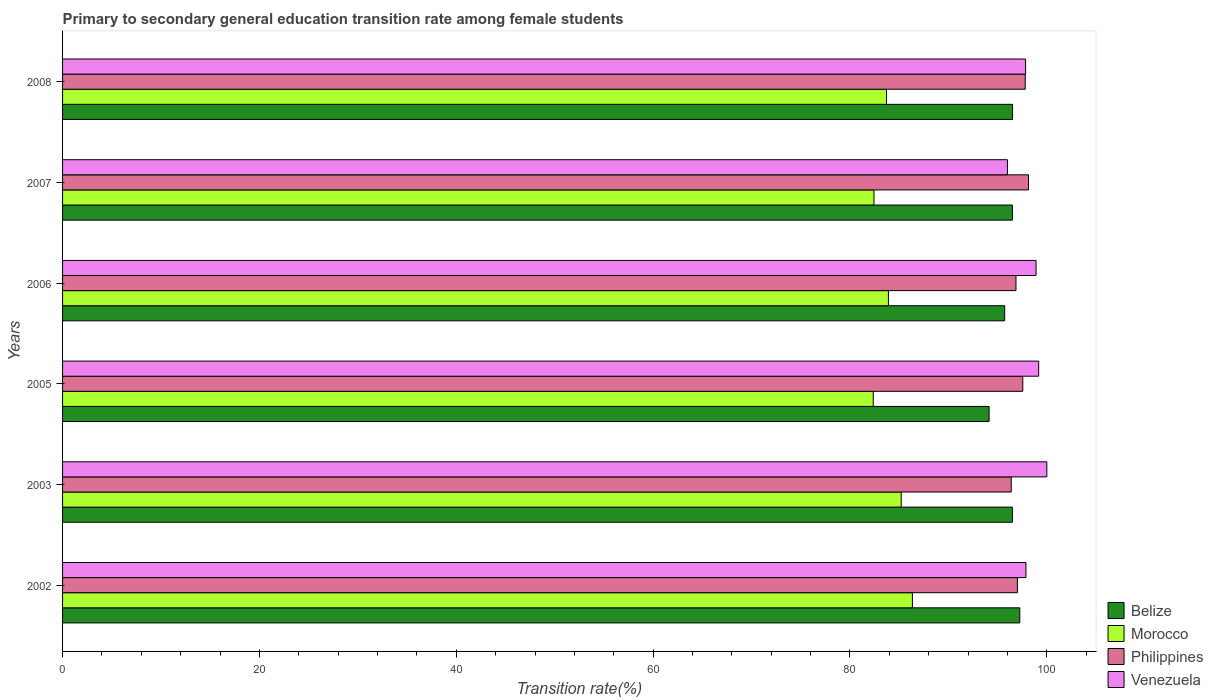How many different coloured bars are there?
Ensure brevity in your answer.  4. How many groups of bars are there?
Your response must be concise. 6. How many bars are there on the 5th tick from the top?
Offer a very short reply. 4. What is the label of the 1st group of bars from the top?
Provide a short and direct response. 2008. Across all years, what is the minimum transition rate in Morocco?
Keep it short and to the point. 82.36. What is the total transition rate in Belize in the graph?
Offer a very short reply. 576.63. What is the difference between the transition rate in Morocco in 2005 and that in 2007?
Give a very brief answer. -0.08. What is the difference between the transition rate in Morocco in 2005 and the transition rate in Philippines in 2002?
Your answer should be very brief. -14.65. What is the average transition rate in Morocco per year?
Give a very brief answer. 83.99. In the year 2006, what is the difference between the transition rate in Venezuela and transition rate in Belize?
Provide a short and direct response. 3.19. In how many years, is the transition rate in Philippines greater than 56 %?
Your answer should be very brief. 6. What is the ratio of the transition rate in Morocco in 2003 to that in 2005?
Give a very brief answer. 1.03. Is the transition rate in Belize in 2005 less than that in 2006?
Make the answer very short. Yes. Is the difference between the transition rate in Venezuela in 2003 and 2007 greater than the difference between the transition rate in Belize in 2003 and 2007?
Give a very brief answer. Yes. What is the difference between the highest and the second highest transition rate in Philippines?
Make the answer very short. 0.33. What is the difference between the highest and the lowest transition rate in Venezuela?
Make the answer very short. 4. In how many years, is the transition rate in Morocco greater than the average transition rate in Morocco taken over all years?
Your answer should be very brief. 2. What does the 4th bar from the top in 2008 represents?
Provide a succinct answer. Belize. What does the 4th bar from the bottom in 2003 represents?
Your response must be concise. Venezuela. Is it the case that in every year, the sum of the transition rate in Morocco and transition rate in Venezuela is greater than the transition rate in Philippines?
Your answer should be very brief. Yes. How many bars are there?
Your response must be concise. 24. Where does the legend appear in the graph?
Your response must be concise. Bottom right. How are the legend labels stacked?
Keep it short and to the point. Vertical. What is the title of the graph?
Make the answer very short. Primary to secondary general education transition rate among female students. What is the label or title of the X-axis?
Ensure brevity in your answer.  Transition rate(%). What is the Transition rate(%) in Belize in 2002?
Offer a very short reply. 97.25. What is the Transition rate(%) of Morocco in 2002?
Offer a very short reply. 86.34. What is the Transition rate(%) in Philippines in 2002?
Make the answer very short. 97.01. What is the Transition rate(%) in Venezuela in 2002?
Offer a very short reply. 97.88. What is the Transition rate(%) in Belize in 2003?
Provide a succinct answer. 96.5. What is the Transition rate(%) of Morocco in 2003?
Provide a succinct answer. 85.21. What is the Transition rate(%) in Philippines in 2003?
Provide a short and direct response. 96.38. What is the Transition rate(%) of Venezuela in 2003?
Provide a short and direct response. 100. What is the Transition rate(%) of Belize in 2005?
Keep it short and to the point. 94.13. What is the Transition rate(%) in Morocco in 2005?
Provide a succinct answer. 82.36. What is the Transition rate(%) of Philippines in 2005?
Provide a succinct answer. 97.56. What is the Transition rate(%) in Venezuela in 2005?
Ensure brevity in your answer.  99.17. What is the Transition rate(%) of Belize in 2006?
Provide a short and direct response. 95.72. What is the Transition rate(%) in Morocco in 2006?
Give a very brief answer. 83.91. What is the Transition rate(%) of Philippines in 2006?
Provide a short and direct response. 96.86. What is the Transition rate(%) of Venezuela in 2006?
Your answer should be compact. 98.91. What is the Transition rate(%) of Belize in 2007?
Ensure brevity in your answer.  96.51. What is the Transition rate(%) in Morocco in 2007?
Your answer should be compact. 82.44. What is the Transition rate(%) in Philippines in 2007?
Offer a terse response. 98.14. What is the Transition rate(%) in Venezuela in 2007?
Ensure brevity in your answer.  96. What is the Transition rate(%) of Belize in 2008?
Provide a succinct answer. 96.52. What is the Transition rate(%) of Morocco in 2008?
Make the answer very short. 83.71. What is the Transition rate(%) of Philippines in 2008?
Give a very brief answer. 97.8. What is the Transition rate(%) of Venezuela in 2008?
Provide a short and direct response. 97.84. Across all years, what is the maximum Transition rate(%) in Belize?
Give a very brief answer. 97.25. Across all years, what is the maximum Transition rate(%) in Morocco?
Your response must be concise. 86.34. Across all years, what is the maximum Transition rate(%) of Philippines?
Keep it short and to the point. 98.14. Across all years, what is the minimum Transition rate(%) in Belize?
Keep it short and to the point. 94.13. Across all years, what is the minimum Transition rate(%) in Morocco?
Make the answer very short. 82.36. Across all years, what is the minimum Transition rate(%) in Philippines?
Ensure brevity in your answer.  96.38. Across all years, what is the minimum Transition rate(%) in Venezuela?
Provide a short and direct response. 96. What is the total Transition rate(%) in Belize in the graph?
Ensure brevity in your answer.  576.63. What is the total Transition rate(%) in Morocco in the graph?
Your answer should be very brief. 503.97. What is the total Transition rate(%) of Philippines in the graph?
Offer a terse response. 583.76. What is the total Transition rate(%) in Venezuela in the graph?
Ensure brevity in your answer.  589.8. What is the difference between the Transition rate(%) of Belize in 2002 and that in 2003?
Provide a succinct answer. 0.75. What is the difference between the Transition rate(%) in Morocco in 2002 and that in 2003?
Provide a succinct answer. 1.14. What is the difference between the Transition rate(%) in Philippines in 2002 and that in 2003?
Your response must be concise. 0.63. What is the difference between the Transition rate(%) of Venezuela in 2002 and that in 2003?
Your response must be concise. -2.12. What is the difference between the Transition rate(%) in Belize in 2002 and that in 2005?
Make the answer very short. 3.12. What is the difference between the Transition rate(%) in Morocco in 2002 and that in 2005?
Provide a short and direct response. 3.98. What is the difference between the Transition rate(%) in Philippines in 2002 and that in 2005?
Offer a very short reply. -0.55. What is the difference between the Transition rate(%) in Venezuela in 2002 and that in 2005?
Offer a very short reply. -1.29. What is the difference between the Transition rate(%) in Belize in 2002 and that in 2006?
Offer a very short reply. 1.53. What is the difference between the Transition rate(%) of Morocco in 2002 and that in 2006?
Your response must be concise. 2.44. What is the difference between the Transition rate(%) of Philippines in 2002 and that in 2006?
Ensure brevity in your answer.  0.15. What is the difference between the Transition rate(%) in Venezuela in 2002 and that in 2006?
Offer a very short reply. -1.02. What is the difference between the Transition rate(%) of Belize in 2002 and that in 2007?
Keep it short and to the point. 0.74. What is the difference between the Transition rate(%) of Morocco in 2002 and that in 2007?
Provide a succinct answer. 3.9. What is the difference between the Transition rate(%) in Philippines in 2002 and that in 2007?
Your answer should be compact. -1.13. What is the difference between the Transition rate(%) in Venezuela in 2002 and that in 2007?
Your answer should be compact. 1.88. What is the difference between the Transition rate(%) in Belize in 2002 and that in 2008?
Ensure brevity in your answer.  0.73. What is the difference between the Transition rate(%) in Morocco in 2002 and that in 2008?
Give a very brief answer. 2.63. What is the difference between the Transition rate(%) of Philippines in 2002 and that in 2008?
Your answer should be very brief. -0.79. What is the difference between the Transition rate(%) of Venezuela in 2002 and that in 2008?
Offer a terse response. 0.04. What is the difference between the Transition rate(%) of Belize in 2003 and that in 2005?
Offer a very short reply. 2.37. What is the difference between the Transition rate(%) in Morocco in 2003 and that in 2005?
Provide a succinct answer. 2.84. What is the difference between the Transition rate(%) in Philippines in 2003 and that in 2005?
Offer a very short reply. -1.17. What is the difference between the Transition rate(%) in Venezuela in 2003 and that in 2005?
Offer a terse response. 0.83. What is the difference between the Transition rate(%) of Belize in 2003 and that in 2006?
Provide a short and direct response. 0.78. What is the difference between the Transition rate(%) in Morocco in 2003 and that in 2006?
Your response must be concise. 1.3. What is the difference between the Transition rate(%) of Philippines in 2003 and that in 2006?
Your response must be concise. -0.48. What is the difference between the Transition rate(%) in Venezuela in 2003 and that in 2006?
Keep it short and to the point. 1.09. What is the difference between the Transition rate(%) in Belize in 2003 and that in 2007?
Give a very brief answer. -0.01. What is the difference between the Transition rate(%) in Morocco in 2003 and that in 2007?
Offer a terse response. 2.77. What is the difference between the Transition rate(%) of Philippines in 2003 and that in 2007?
Your answer should be very brief. -1.75. What is the difference between the Transition rate(%) in Venezuela in 2003 and that in 2007?
Your answer should be very brief. 4. What is the difference between the Transition rate(%) of Belize in 2003 and that in 2008?
Keep it short and to the point. -0.02. What is the difference between the Transition rate(%) in Morocco in 2003 and that in 2008?
Your answer should be very brief. 1.5. What is the difference between the Transition rate(%) of Philippines in 2003 and that in 2008?
Offer a very short reply. -1.42. What is the difference between the Transition rate(%) in Venezuela in 2003 and that in 2008?
Ensure brevity in your answer.  2.16. What is the difference between the Transition rate(%) of Belize in 2005 and that in 2006?
Your answer should be very brief. -1.58. What is the difference between the Transition rate(%) in Morocco in 2005 and that in 2006?
Ensure brevity in your answer.  -1.54. What is the difference between the Transition rate(%) of Philippines in 2005 and that in 2006?
Your answer should be very brief. 0.69. What is the difference between the Transition rate(%) in Venezuela in 2005 and that in 2006?
Your response must be concise. 0.27. What is the difference between the Transition rate(%) of Belize in 2005 and that in 2007?
Provide a short and direct response. -2.37. What is the difference between the Transition rate(%) in Morocco in 2005 and that in 2007?
Ensure brevity in your answer.  -0.08. What is the difference between the Transition rate(%) in Philippines in 2005 and that in 2007?
Give a very brief answer. -0.58. What is the difference between the Transition rate(%) in Venezuela in 2005 and that in 2007?
Offer a terse response. 3.17. What is the difference between the Transition rate(%) in Belize in 2005 and that in 2008?
Your answer should be compact. -2.38. What is the difference between the Transition rate(%) in Morocco in 2005 and that in 2008?
Your answer should be compact. -1.35. What is the difference between the Transition rate(%) in Philippines in 2005 and that in 2008?
Give a very brief answer. -0.25. What is the difference between the Transition rate(%) in Venezuela in 2005 and that in 2008?
Provide a succinct answer. 1.33. What is the difference between the Transition rate(%) in Belize in 2006 and that in 2007?
Your response must be concise. -0.79. What is the difference between the Transition rate(%) in Morocco in 2006 and that in 2007?
Give a very brief answer. 1.47. What is the difference between the Transition rate(%) of Philippines in 2006 and that in 2007?
Offer a very short reply. -1.27. What is the difference between the Transition rate(%) of Venezuela in 2006 and that in 2007?
Your response must be concise. 2.9. What is the difference between the Transition rate(%) of Belize in 2006 and that in 2008?
Give a very brief answer. -0.8. What is the difference between the Transition rate(%) of Morocco in 2006 and that in 2008?
Make the answer very short. 0.2. What is the difference between the Transition rate(%) of Philippines in 2006 and that in 2008?
Keep it short and to the point. -0.94. What is the difference between the Transition rate(%) of Venezuela in 2006 and that in 2008?
Provide a short and direct response. 1.07. What is the difference between the Transition rate(%) in Belize in 2007 and that in 2008?
Ensure brevity in your answer.  -0.01. What is the difference between the Transition rate(%) in Morocco in 2007 and that in 2008?
Your response must be concise. -1.27. What is the difference between the Transition rate(%) of Philippines in 2007 and that in 2008?
Your answer should be very brief. 0.33. What is the difference between the Transition rate(%) of Venezuela in 2007 and that in 2008?
Offer a very short reply. -1.84. What is the difference between the Transition rate(%) in Belize in 2002 and the Transition rate(%) in Morocco in 2003?
Ensure brevity in your answer.  12.05. What is the difference between the Transition rate(%) in Belize in 2002 and the Transition rate(%) in Philippines in 2003?
Keep it short and to the point. 0.87. What is the difference between the Transition rate(%) in Belize in 2002 and the Transition rate(%) in Venezuela in 2003?
Offer a terse response. -2.75. What is the difference between the Transition rate(%) in Morocco in 2002 and the Transition rate(%) in Philippines in 2003?
Offer a very short reply. -10.04. What is the difference between the Transition rate(%) of Morocco in 2002 and the Transition rate(%) of Venezuela in 2003?
Your answer should be compact. -13.66. What is the difference between the Transition rate(%) in Philippines in 2002 and the Transition rate(%) in Venezuela in 2003?
Your answer should be compact. -2.99. What is the difference between the Transition rate(%) in Belize in 2002 and the Transition rate(%) in Morocco in 2005?
Give a very brief answer. 14.89. What is the difference between the Transition rate(%) of Belize in 2002 and the Transition rate(%) of Philippines in 2005?
Your response must be concise. -0.31. What is the difference between the Transition rate(%) in Belize in 2002 and the Transition rate(%) in Venezuela in 2005?
Make the answer very short. -1.92. What is the difference between the Transition rate(%) in Morocco in 2002 and the Transition rate(%) in Philippines in 2005?
Provide a short and direct response. -11.21. What is the difference between the Transition rate(%) of Morocco in 2002 and the Transition rate(%) of Venezuela in 2005?
Give a very brief answer. -12.83. What is the difference between the Transition rate(%) in Philippines in 2002 and the Transition rate(%) in Venezuela in 2005?
Your answer should be compact. -2.16. What is the difference between the Transition rate(%) of Belize in 2002 and the Transition rate(%) of Morocco in 2006?
Give a very brief answer. 13.34. What is the difference between the Transition rate(%) in Belize in 2002 and the Transition rate(%) in Philippines in 2006?
Your response must be concise. 0.39. What is the difference between the Transition rate(%) in Belize in 2002 and the Transition rate(%) in Venezuela in 2006?
Your response must be concise. -1.65. What is the difference between the Transition rate(%) in Morocco in 2002 and the Transition rate(%) in Philippines in 2006?
Offer a terse response. -10.52. What is the difference between the Transition rate(%) of Morocco in 2002 and the Transition rate(%) of Venezuela in 2006?
Your response must be concise. -12.56. What is the difference between the Transition rate(%) of Philippines in 2002 and the Transition rate(%) of Venezuela in 2006?
Offer a very short reply. -1.9. What is the difference between the Transition rate(%) in Belize in 2002 and the Transition rate(%) in Morocco in 2007?
Provide a succinct answer. 14.81. What is the difference between the Transition rate(%) of Belize in 2002 and the Transition rate(%) of Philippines in 2007?
Keep it short and to the point. -0.89. What is the difference between the Transition rate(%) of Belize in 2002 and the Transition rate(%) of Venezuela in 2007?
Give a very brief answer. 1.25. What is the difference between the Transition rate(%) of Morocco in 2002 and the Transition rate(%) of Philippines in 2007?
Your response must be concise. -11.79. What is the difference between the Transition rate(%) in Morocco in 2002 and the Transition rate(%) in Venezuela in 2007?
Ensure brevity in your answer.  -9.66. What is the difference between the Transition rate(%) in Philippines in 2002 and the Transition rate(%) in Venezuela in 2007?
Keep it short and to the point. 1.01. What is the difference between the Transition rate(%) of Belize in 2002 and the Transition rate(%) of Morocco in 2008?
Provide a short and direct response. 13.54. What is the difference between the Transition rate(%) in Belize in 2002 and the Transition rate(%) in Philippines in 2008?
Keep it short and to the point. -0.55. What is the difference between the Transition rate(%) in Belize in 2002 and the Transition rate(%) in Venezuela in 2008?
Ensure brevity in your answer.  -0.59. What is the difference between the Transition rate(%) in Morocco in 2002 and the Transition rate(%) in Philippines in 2008?
Provide a succinct answer. -11.46. What is the difference between the Transition rate(%) in Morocco in 2002 and the Transition rate(%) in Venezuela in 2008?
Keep it short and to the point. -11.5. What is the difference between the Transition rate(%) in Philippines in 2002 and the Transition rate(%) in Venezuela in 2008?
Make the answer very short. -0.83. What is the difference between the Transition rate(%) in Belize in 2003 and the Transition rate(%) in Morocco in 2005?
Your answer should be very brief. 14.14. What is the difference between the Transition rate(%) in Belize in 2003 and the Transition rate(%) in Philippines in 2005?
Provide a short and direct response. -1.06. What is the difference between the Transition rate(%) of Belize in 2003 and the Transition rate(%) of Venezuela in 2005?
Your response must be concise. -2.67. What is the difference between the Transition rate(%) of Morocco in 2003 and the Transition rate(%) of Philippines in 2005?
Your response must be concise. -12.35. What is the difference between the Transition rate(%) of Morocco in 2003 and the Transition rate(%) of Venezuela in 2005?
Make the answer very short. -13.97. What is the difference between the Transition rate(%) of Philippines in 2003 and the Transition rate(%) of Venezuela in 2005?
Give a very brief answer. -2.79. What is the difference between the Transition rate(%) of Belize in 2003 and the Transition rate(%) of Morocco in 2006?
Ensure brevity in your answer.  12.6. What is the difference between the Transition rate(%) of Belize in 2003 and the Transition rate(%) of Philippines in 2006?
Ensure brevity in your answer.  -0.36. What is the difference between the Transition rate(%) in Belize in 2003 and the Transition rate(%) in Venezuela in 2006?
Give a very brief answer. -2.4. What is the difference between the Transition rate(%) in Morocco in 2003 and the Transition rate(%) in Philippines in 2006?
Your answer should be compact. -11.66. What is the difference between the Transition rate(%) in Morocco in 2003 and the Transition rate(%) in Venezuela in 2006?
Ensure brevity in your answer.  -13.7. What is the difference between the Transition rate(%) of Philippines in 2003 and the Transition rate(%) of Venezuela in 2006?
Make the answer very short. -2.52. What is the difference between the Transition rate(%) in Belize in 2003 and the Transition rate(%) in Morocco in 2007?
Your answer should be very brief. 14.06. What is the difference between the Transition rate(%) of Belize in 2003 and the Transition rate(%) of Philippines in 2007?
Ensure brevity in your answer.  -1.63. What is the difference between the Transition rate(%) of Belize in 2003 and the Transition rate(%) of Venezuela in 2007?
Ensure brevity in your answer.  0.5. What is the difference between the Transition rate(%) of Morocco in 2003 and the Transition rate(%) of Philippines in 2007?
Your answer should be very brief. -12.93. What is the difference between the Transition rate(%) of Morocco in 2003 and the Transition rate(%) of Venezuela in 2007?
Offer a terse response. -10.8. What is the difference between the Transition rate(%) of Philippines in 2003 and the Transition rate(%) of Venezuela in 2007?
Your answer should be very brief. 0.38. What is the difference between the Transition rate(%) in Belize in 2003 and the Transition rate(%) in Morocco in 2008?
Your answer should be compact. 12.79. What is the difference between the Transition rate(%) of Belize in 2003 and the Transition rate(%) of Philippines in 2008?
Your answer should be very brief. -1.3. What is the difference between the Transition rate(%) in Belize in 2003 and the Transition rate(%) in Venezuela in 2008?
Provide a short and direct response. -1.34. What is the difference between the Transition rate(%) in Morocco in 2003 and the Transition rate(%) in Philippines in 2008?
Offer a very short reply. -12.6. What is the difference between the Transition rate(%) in Morocco in 2003 and the Transition rate(%) in Venezuela in 2008?
Offer a very short reply. -12.63. What is the difference between the Transition rate(%) in Philippines in 2003 and the Transition rate(%) in Venezuela in 2008?
Offer a terse response. -1.46. What is the difference between the Transition rate(%) of Belize in 2005 and the Transition rate(%) of Morocco in 2006?
Your answer should be compact. 10.23. What is the difference between the Transition rate(%) in Belize in 2005 and the Transition rate(%) in Philippines in 2006?
Keep it short and to the point. -2.73. What is the difference between the Transition rate(%) in Belize in 2005 and the Transition rate(%) in Venezuela in 2006?
Your response must be concise. -4.77. What is the difference between the Transition rate(%) in Morocco in 2005 and the Transition rate(%) in Philippines in 2006?
Ensure brevity in your answer.  -14.5. What is the difference between the Transition rate(%) in Morocco in 2005 and the Transition rate(%) in Venezuela in 2006?
Make the answer very short. -16.54. What is the difference between the Transition rate(%) of Philippines in 2005 and the Transition rate(%) of Venezuela in 2006?
Provide a short and direct response. -1.35. What is the difference between the Transition rate(%) of Belize in 2005 and the Transition rate(%) of Morocco in 2007?
Your response must be concise. 11.7. What is the difference between the Transition rate(%) in Belize in 2005 and the Transition rate(%) in Philippines in 2007?
Your answer should be very brief. -4. What is the difference between the Transition rate(%) of Belize in 2005 and the Transition rate(%) of Venezuela in 2007?
Provide a succinct answer. -1.87. What is the difference between the Transition rate(%) of Morocco in 2005 and the Transition rate(%) of Philippines in 2007?
Provide a short and direct response. -15.77. What is the difference between the Transition rate(%) in Morocco in 2005 and the Transition rate(%) in Venezuela in 2007?
Ensure brevity in your answer.  -13.64. What is the difference between the Transition rate(%) of Philippines in 2005 and the Transition rate(%) of Venezuela in 2007?
Your response must be concise. 1.56. What is the difference between the Transition rate(%) in Belize in 2005 and the Transition rate(%) in Morocco in 2008?
Offer a terse response. 10.42. What is the difference between the Transition rate(%) in Belize in 2005 and the Transition rate(%) in Philippines in 2008?
Keep it short and to the point. -3.67. What is the difference between the Transition rate(%) of Belize in 2005 and the Transition rate(%) of Venezuela in 2008?
Provide a succinct answer. -3.71. What is the difference between the Transition rate(%) of Morocco in 2005 and the Transition rate(%) of Philippines in 2008?
Give a very brief answer. -15.44. What is the difference between the Transition rate(%) of Morocco in 2005 and the Transition rate(%) of Venezuela in 2008?
Keep it short and to the point. -15.48. What is the difference between the Transition rate(%) in Philippines in 2005 and the Transition rate(%) in Venezuela in 2008?
Make the answer very short. -0.28. What is the difference between the Transition rate(%) in Belize in 2006 and the Transition rate(%) in Morocco in 2007?
Keep it short and to the point. 13.28. What is the difference between the Transition rate(%) of Belize in 2006 and the Transition rate(%) of Philippines in 2007?
Provide a short and direct response. -2.42. What is the difference between the Transition rate(%) of Belize in 2006 and the Transition rate(%) of Venezuela in 2007?
Your answer should be very brief. -0.28. What is the difference between the Transition rate(%) in Morocco in 2006 and the Transition rate(%) in Philippines in 2007?
Your response must be concise. -14.23. What is the difference between the Transition rate(%) in Morocco in 2006 and the Transition rate(%) in Venezuela in 2007?
Give a very brief answer. -12.1. What is the difference between the Transition rate(%) of Philippines in 2006 and the Transition rate(%) of Venezuela in 2007?
Give a very brief answer. 0.86. What is the difference between the Transition rate(%) of Belize in 2006 and the Transition rate(%) of Morocco in 2008?
Make the answer very short. 12.01. What is the difference between the Transition rate(%) of Belize in 2006 and the Transition rate(%) of Philippines in 2008?
Provide a succinct answer. -2.09. What is the difference between the Transition rate(%) of Belize in 2006 and the Transition rate(%) of Venezuela in 2008?
Ensure brevity in your answer.  -2.12. What is the difference between the Transition rate(%) in Morocco in 2006 and the Transition rate(%) in Philippines in 2008?
Offer a terse response. -13.9. What is the difference between the Transition rate(%) in Morocco in 2006 and the Transition rate(%) in Venezuela in 2008?
Offer a very short reply. -13.93. What is the difference between the Transition rate(%) in Philippines in 2006 and the Transition rate(%) in Venezuela in 2008?
Provide a short and direct response. -0.98. What is the difference between the Transition rate(%) of Belize in 2007 and the Transition rate(%) of Morocco in 2008?
Provide a short and direct response. 12.8. What is the difference between the Transition rate(%) in Belize in 2007 and the Transition rate(%) in Philippines in 2008?
Ensure brevity in your answer.  -1.3. What is the difference between the Transition rate(%) in Belize in 2007 and the Transition rate(%) in Venezuela in 2008?
Give a very brief answer. -1.33. What is the difference between the Transition rate(%) of Morocco in 2007 and the Transition rate(%) of Philippines in 2008?
Keep it short and to the point. -15.37. What is the difference between the Transition rate(%) in Morocco in 2007 and the Transition rate(%) in Venezuela in 2008?
Your answer should be compact. -15.4. What is the difference between the Transition rate(%) in Philippines in 2007 and the Transition rate(%) in Venezuela in 2008?
Keep it short and to the point. 0.3. What is the average Transition rate(%) in Belize per year?
Keep it short and to the point. 96.11. What is the average Transition rate(%) in Morocco per year?
Your answer should be compact. 83.99. What is the average Transition rate(%) of Philippines per year?
Ensure brevity in your answer.  97.29. What is the average Transition rate(%) of Venezuela per year?
Provide a succinct answer. 98.3. In the year 2002, what is the difference between the Transition rate(%) of Belize and Transition rate(%) of Morocco?
Offer a terse response. 10.91. In the year 2002, what is the difference between the Transition rate(%) in Belize and Transition rate(%) in Philippines?
Your answer should be compact. 0.24. In the year 2002, what is the difference between the Transition rate(%) in Belize and Transition rate(%) in Venezuela?
Your answer should be compact. -0.63. In the year 2002, what is the difference between the Transition rate(%) of Morocco and Transition rate(%) of Philippines?
Ensure brevity in your answer.  -10.67. In the year 2002, what is the difference between the Transition rate(%) of Morocco and Transition rate(%) of Venezuela?
Provide a succinct answer. -11.54. In the year 2002, what is the difference between the Transition rate(%) of Philippines and Transition rate(%) of Venezuela?
Keep it short and to the point. -0.87. In the year 2003, what is the difference between the Transition rate(%) in Belize and Transition rate(%) in Morocco?
Keep it short and to the point. 11.3. In the year 2003, what is the difference between the Transition rate(%) of Belize and Transition rate(%) of Philippines?
Your answer should be compact. 0.12. In the year 2003, what is the difference between the Transition rate(%) in Belize and Transition rate(%) in Venezuela?
Make the answer very short. -3.5. In the year 2003, what is the difference between the Transition rate(%) of Morocco and Transition rate(%) of Philippines?
Your answer should be compact. -11.18. In the year 2003, what is the difference between the Transition rate(%) of Morocco and Transition rate(%) of Venezuela?
Make the answer very short. -14.79. In the year 2003, what is the difference between the Transition rate(%) in Philippines and Transition rate(%) in Venezuela?
Your response must be concise. -3.62. In the year 2005, what is the difference between the Transition rate(%) of Belize and Transition rate(%) of Morocco?
Provide a succinct answer. 11.77. In the year 2005, what is the difference between the Transition rate(%) of Belize and Transition rate(%) of Philippines?
Offer a very short reply. -3.42. In the year 2005, what is the difference between the Transition rate(%) of Belize and Transition rate(%) of Venezuela?
Your answer should be compact. -5.04. In the year 2005, what is the difference between the Transition rate(%) in Morocco and Transition rate(%) in Philippines?
Ensure brevity in your answer.  -15.2. In the year 2005, what is the difference between the Transition rate(%) in Morocco and Transition rate(%) in Venezuela?
Keep it short and to the point. -16.81. In the year 2005, what is the difference between the Transition rate(%) in Philippines and Transition rate(%) in Venezuela?
Keep it short and to the point. -1.61. In the year 2006, what is the difference between the Transition rate(%) of Belize and Transition rate(%) of Morocco?
Make the answer very short. 11.81. In the year 2006, what is the difference between the Transition rate(%) of Belize and Transition rate(%) of Philippines?
Your answer should be compact. -1.15. In the year 2006, what is the difference between the Transition rate(%) of Belize and Transition rate(%) of Venezuela?
Provide a succinct answer. -3.19. In the year 2006, what is the difference between the Transition rate(%) in Morocco and Transition rate(%) in Philippines?
Your answer should be very brief. -12.96. In the year 2006, what is the difference between the Transition rate(%) in Morocco and Transition rate(%) in Venezuela?
Your response must be concise. -15. In the year 2006, what is the difference between the Transition rate(%) of Philippines and Transition rate(%) of Venezuela?
Provide a succinct answer. -2.04. In the year 2007, what is the difference between the Transition rate(%) of Belize and Transition rate(%) of Morocco?
Give a very brief answer. 14.07. In the year 2007, what is the difference between the Transition rate(%) in Belize and Transition rate(%) in Philippines?
Your response must be concise. -1.63. In the year 2007, what is the difference between the Transition rate(%) of Belize and Transition rate(%) of Venezuela?
Offer a terse response. 0.51. In the year 2007, what is the difference between the Transition rate(%) in Morocco and Transition rate(%) in Philippines?
Provide a short and direct response. -15.7. In the year 2007, what is the difference between the Transition rate(%) in Morocco and Transition rate(%) in Venezuela?
Your answer should be compact. -13.56. In the year 2007, what is the difference between the Transition rate(%) in Philippines and Transition rate(%) in Venezuela?
Ensure brevity in your answer.  2.13. In the year 2008, what is the difference between the Transition rate(%) in Belize and Transition rate(%) in Morocco?
Give a very brief answer. 12.81. In the year 2008, what is the difference between the Transition rate(%) in Belize and Transition rate(%) in Philippines?
Give a very brief answer. -1.28. In the year 2008, what is the difference between the Transition rate(%) in Belize and Transition rate(%) in Venezuela?
Your answer should be compact. -1.32. In the year 2008, what is the difference between the Transition rate(%) in Morocco and Transition rate(%) in Philippines?
Your answer should be very brief. -14.09. In the year 2008, what is the difference between the Transition rate(%) in Morocco and Transition rate(%) in Venezuela?
Your answer should be compact. -14.13. In the year 2008, what is the difference between the Transition rate(%) in Philippines and Transition rate(%) in Venezuela?
Your answer should be compact. -0.04. What is the ratio of the Transition rate(%) of Belize in 2002 to that in 2003?
Offer a very short reply. 1.01. What is the ratio of the Transition rate(%) in Morocco in 2002 to that in 2003?
Your response must be concise. 1.01. What is the ratio of the Transition rate(%) in Philippines in 2002 to that in 2003?
Keep it short and to the point. 1.01. What is the ratio of the Transition rate(%) of Venezuela in 2002 to that in 2003?
Make the answer very short. 0.98. What is the ratio of the Transition rate(%) of Belize in 2002 to that in 2005?
Provide a short and direct response. 1.03. What is the ratio of the Transition rate(%) in Morocco in 2002 to that in 2005?
Offer a very short reply. 1.05. What is the ratio of the Transition rate(%) in Philippines in 2002 to that in 2005?
Keep it short and to the point. 0.99. What is the ratio of the Transition rate(%) in Venezuela in 2002 to that in 2005?
Give a very brief answer. 0.99. What is the ratio of the Transition rate(%) of Belize in 2002 to that in 2006?
Your response must be concise. 1.02. What is the ratio of the Transition rate(%) of Philippines in 2002 to that in 2006?
Your answer should be very brief. 1. What is the ratio of the Transition rate(%) of Belize in 2002 to that in 2007?
Your response must be concise. 1.01. What is the ratio of the Transition rate(%) of Morocco in 2002 to that in 2007?
Provide a short and direct response. 1.05. What is the ratio of the Transition rate(%) in Venezuela in 2002 to that in 2007?
Your response must be concise. 1.02. What is the ratio of the Transition rate(%) in Belize in 2002 to that in 2008?
Give a very brief answer. 1.01. What is the ratio of the Transition rate(%) in Morocco in 2002 to that in 2008?
Provide a succinct answer. 1.03. What is the ratio of the Transition rate(%) of Belize in 2003 to that in 2005?
Ensure brevity in your answer.  1.03. What is the ratio of the Transition rate(%) in Morocco in 2003 to that in 2005?
Provide a succinct answer. 1.03. What is the ratio of the Transition rate(%) in Philippines in 2003 to that in 2005?
Offer a very short reply. 0.99. What is the ratio of the Transition rate(%) in Venezuela in 2003 to that in 2005?
Ensure brevity in your answer.  1.01. What is the ratio of the Transition rate(%) in Belize in 2003 to that in 2006?
Provide a succinct answer. 1.01. What is the ratio of the Transition rate(%) of Morocco in 2003 to that in 2006?
Provide a short and direct response. 1.02. What is the ratio of the Transition rate(%) of Philippines in 2003 to that in 2006?
Offer a very short reply. 0.99. What is the ratio of the Transition rate(%) of Venezuela in 2003 to that in 2006?
Keep it short and to the point. 1.01. What is the ratio of the Transition rate(%) in Morocco in 2003 to that in 2007?
Offer a very short reply. 1.03. What is the ratio of the Transition rate(%) in Philippines in 2003 to that in 2007?
Give a very brief answer. 0.98. What is the ratio of the Transition rate(%) of Venezuela in 2003 to that in 2007?
Your answer should be very brief. 1.04. What is the ratio of the Transition rate(%) of Belize in 2003 to that in 2008?
Offer a very short reply. 1. What is the ratio of the Transition rate(%) of Morocco in 2003 to that in 2008?
Provide a succinct answer. 1.02. What is the ratio of the Transition rate(%) in Philippines in 2003 to that in 2008?
Make the answer very short. 0.99. What is the ratio of the Transition rate(%) of Venezuela in 2003 to that in 2008?
Make the answer very short. 1.02. What is the ratio of the Transition rate(%) of Belize in 2005 to that in 2006?
Offer a very short reply. 0.98. What is the ratio of the Transition rate(%) in Morocco in 2005 to that in 2006?
Your answer should be very brief. 0.98. What is the ratio of the Transition rate(%) of Belize in 2005 to that in 2007?
Offer a very short reply. 0.98. What is the ratio of the Transition rate(%) of Morocco in 2005 to that in 2007?
Ensure brevity in your answer.  1. What is the ratio of the Transition rate(%) of Venezuela in 2005 to that in 2007?
Ensure brevity in your answer.  1.03. What is the ratio of the Transition rate(%) of Belize in 2005 to that in 2008?
Your answer should be very brief. 0.98. What is the ratio of the Transition rate(%) of Morocco in 2005 to that in 2008?
Provide a short and direct response. 0.98. What is the ratio of the Transition rate(%) in Philippines in 2005 to that in 2008?
Offer a very short reply. 1. What is the ratio of the Transition rate(%) in Venezuela in 2005 to that in 2008?
Your answer should be very brief. 1.01. What is the ratio of the Transition rate(%) in Belize in 2006 to that in 2007?
Provide a short and direct response. 0.99. What is the ratio of the Transition rate(%) in Morocco in 2006 to that in 2007?
Your answer should be compact. 1.02. What is the ratio of the Transition rate(%) in Venezuela in 2006 to that in 2007?
Your response must be concise. 1.03. What is the ratio of the Transition rate(%) in Belize in 2006 to that in 2008?
Offer a very short reply. 0.99. What is the ratio of the Transition rate(%) of Philippines in 2006 to that in 2008?
Ensure brevity in your answer.  0.99. What is the ratio of the Transition rate(%) in Venezuela in 2006 to that in 2008?
Offer a terse response. 1.01. What is the ratio of the Transition rate(%) in Morocco in 2007 to that in 2008?
Your answer should be very brief. 0.98. What is the ratio of the Transition rate(%) in Philippines in 2007 to that in 2008?
Provide a short and direct response. 1. What is the ratio of the Transition rate(%) of Venezuela in 2007 to that in 2008?
Keep it short and to the point. 0.98. What is the difference between the highest and the second highest Transition rate(%) in Belize?
Your answer should be compact. 0.73. What is the difference between the highest and the second highest Transition rate(%) of Morocco?
Provide a short and direct response. 1.14. What is the difference between the highest and the second highest Transition rate(%) in Philippines?
Offer a very short reply. 0.33. What is the difference between the highest and the second highest Transition rate(%) in Venezuela?
Offer a terse response. 0.83. What is the difference between the highest and the lowest Transition rate(%) of Belize?
Provide a short and direct response. 3.12. What is the difference between the highest and the lowest Transition rate(%) of Morocco?
Give a very brief answer. 3.98. What is the difference between the highest and the lowest Transition rate(%) of Philippines?
Provide a succinct answer. 1.75. What is the difference between the highest and the lowest Transition rate(%) of Venezuela?
Your response must be concise. 4. 